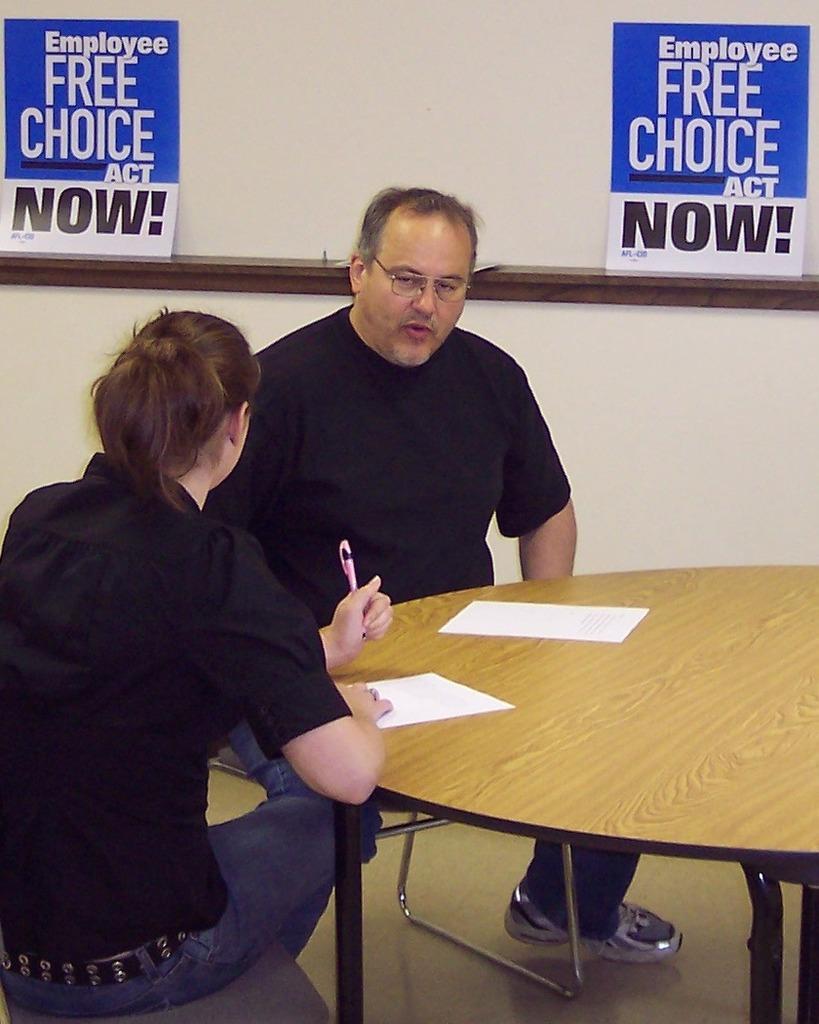Can you describe this image briefly? In this image I can see a two person sitting on the chair. On the table there is a papers woman holding pen. At the back side there is a pamphlets on the wall. On the pamphlet there is a quotation written "Employee free choice act now!" it is in blue color. The wall is in white color. 